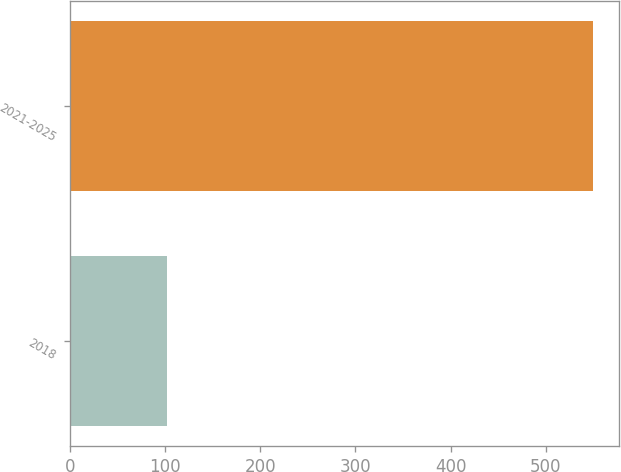<chart> <loc_0><loc_0><loc_500><loc_500><bar_chart><fcel>2018<fcel>2021-2025<nl><fcel>102<fcel>550<nl></chart> 